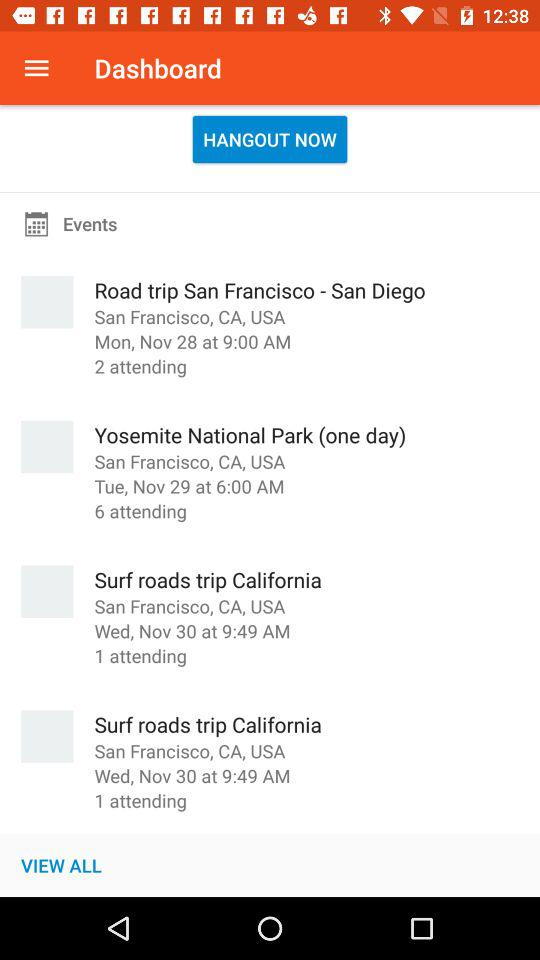How many more people are attending the event 'Yosemite National Park (one day)' than the event 'Surf roads trip California'?
Answer the question using a single word or phrase. 5 